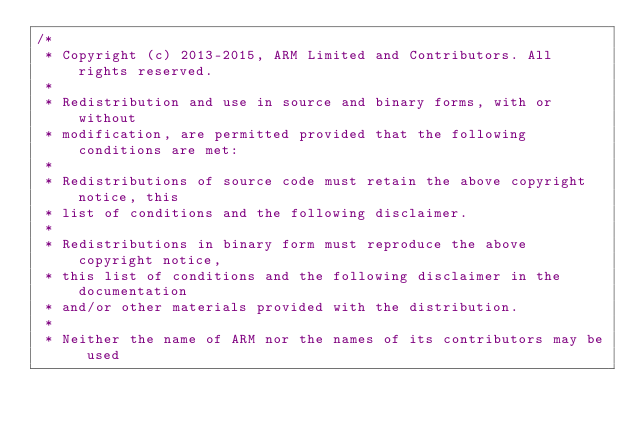Convert code to text. <code><loc_0><loc_0><loc_500><loc_500><_C_>/*
 * Copyright (c) 2013-2015, ARM Limited and Contributors. All rights reserved.
 *
 * Redistribution and use in source and binary forms, with or without
 * modification, are permitted provided that the following conditions are met:
 *
 * Redistributions of source code must retain the above copyright notice, this
 * list of conditions and the following disclaimer.
 *
 * Redistributions in binary form must reproduce the above copyright notice,
 * this list of conditions and the following disclaimer in the documentation
 * and/or other materials provided with the distribution.
 *
 * Neither the name of ARM nor the names of its contributors may be used</code> 